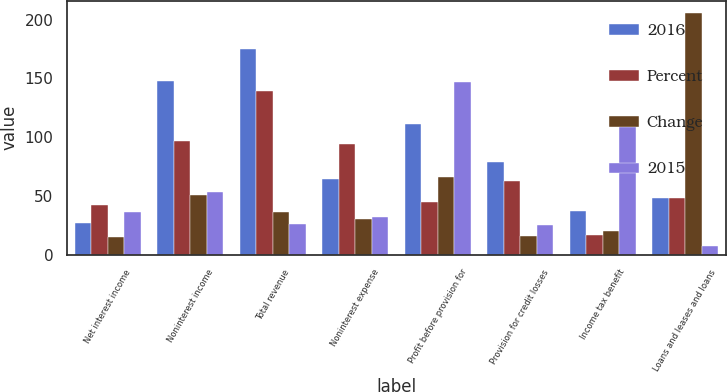<chart> <loc_0><loc_0><loc_500><loc_500><stacked_bar_chart><ecel><fcel>Net interest income<fcel>Noninterest income<fcel>Total revenue<fcel>Noninterest expense<fcel>Profit before provision for<fcel>Provision for credit losses<fcel>Income tax benefit<fcel>Loans and leases and loans<nl><fcel>2016<fcel>27<fcel>148<fcel>175<fcel>64<fcel>111<fcel>79<fcel>37<fcel>48<nl><fcel>Percent<fcel>42<fcel>97<fcel>139<fcel>94<fcel>45<fcel>63<fcel>17<fcel>48<nl><fcel>Change<fcel>15<fcel>51<fcel>36<fcel>30<fcel>66<fcel>16<fcel>20<fcel>206<nl><fcel>2015<fcel>36<fcel>53<fcel>26<fcel>32<fcel>147<fcel>25<fcel>118<fcel>7<nl></chart> 